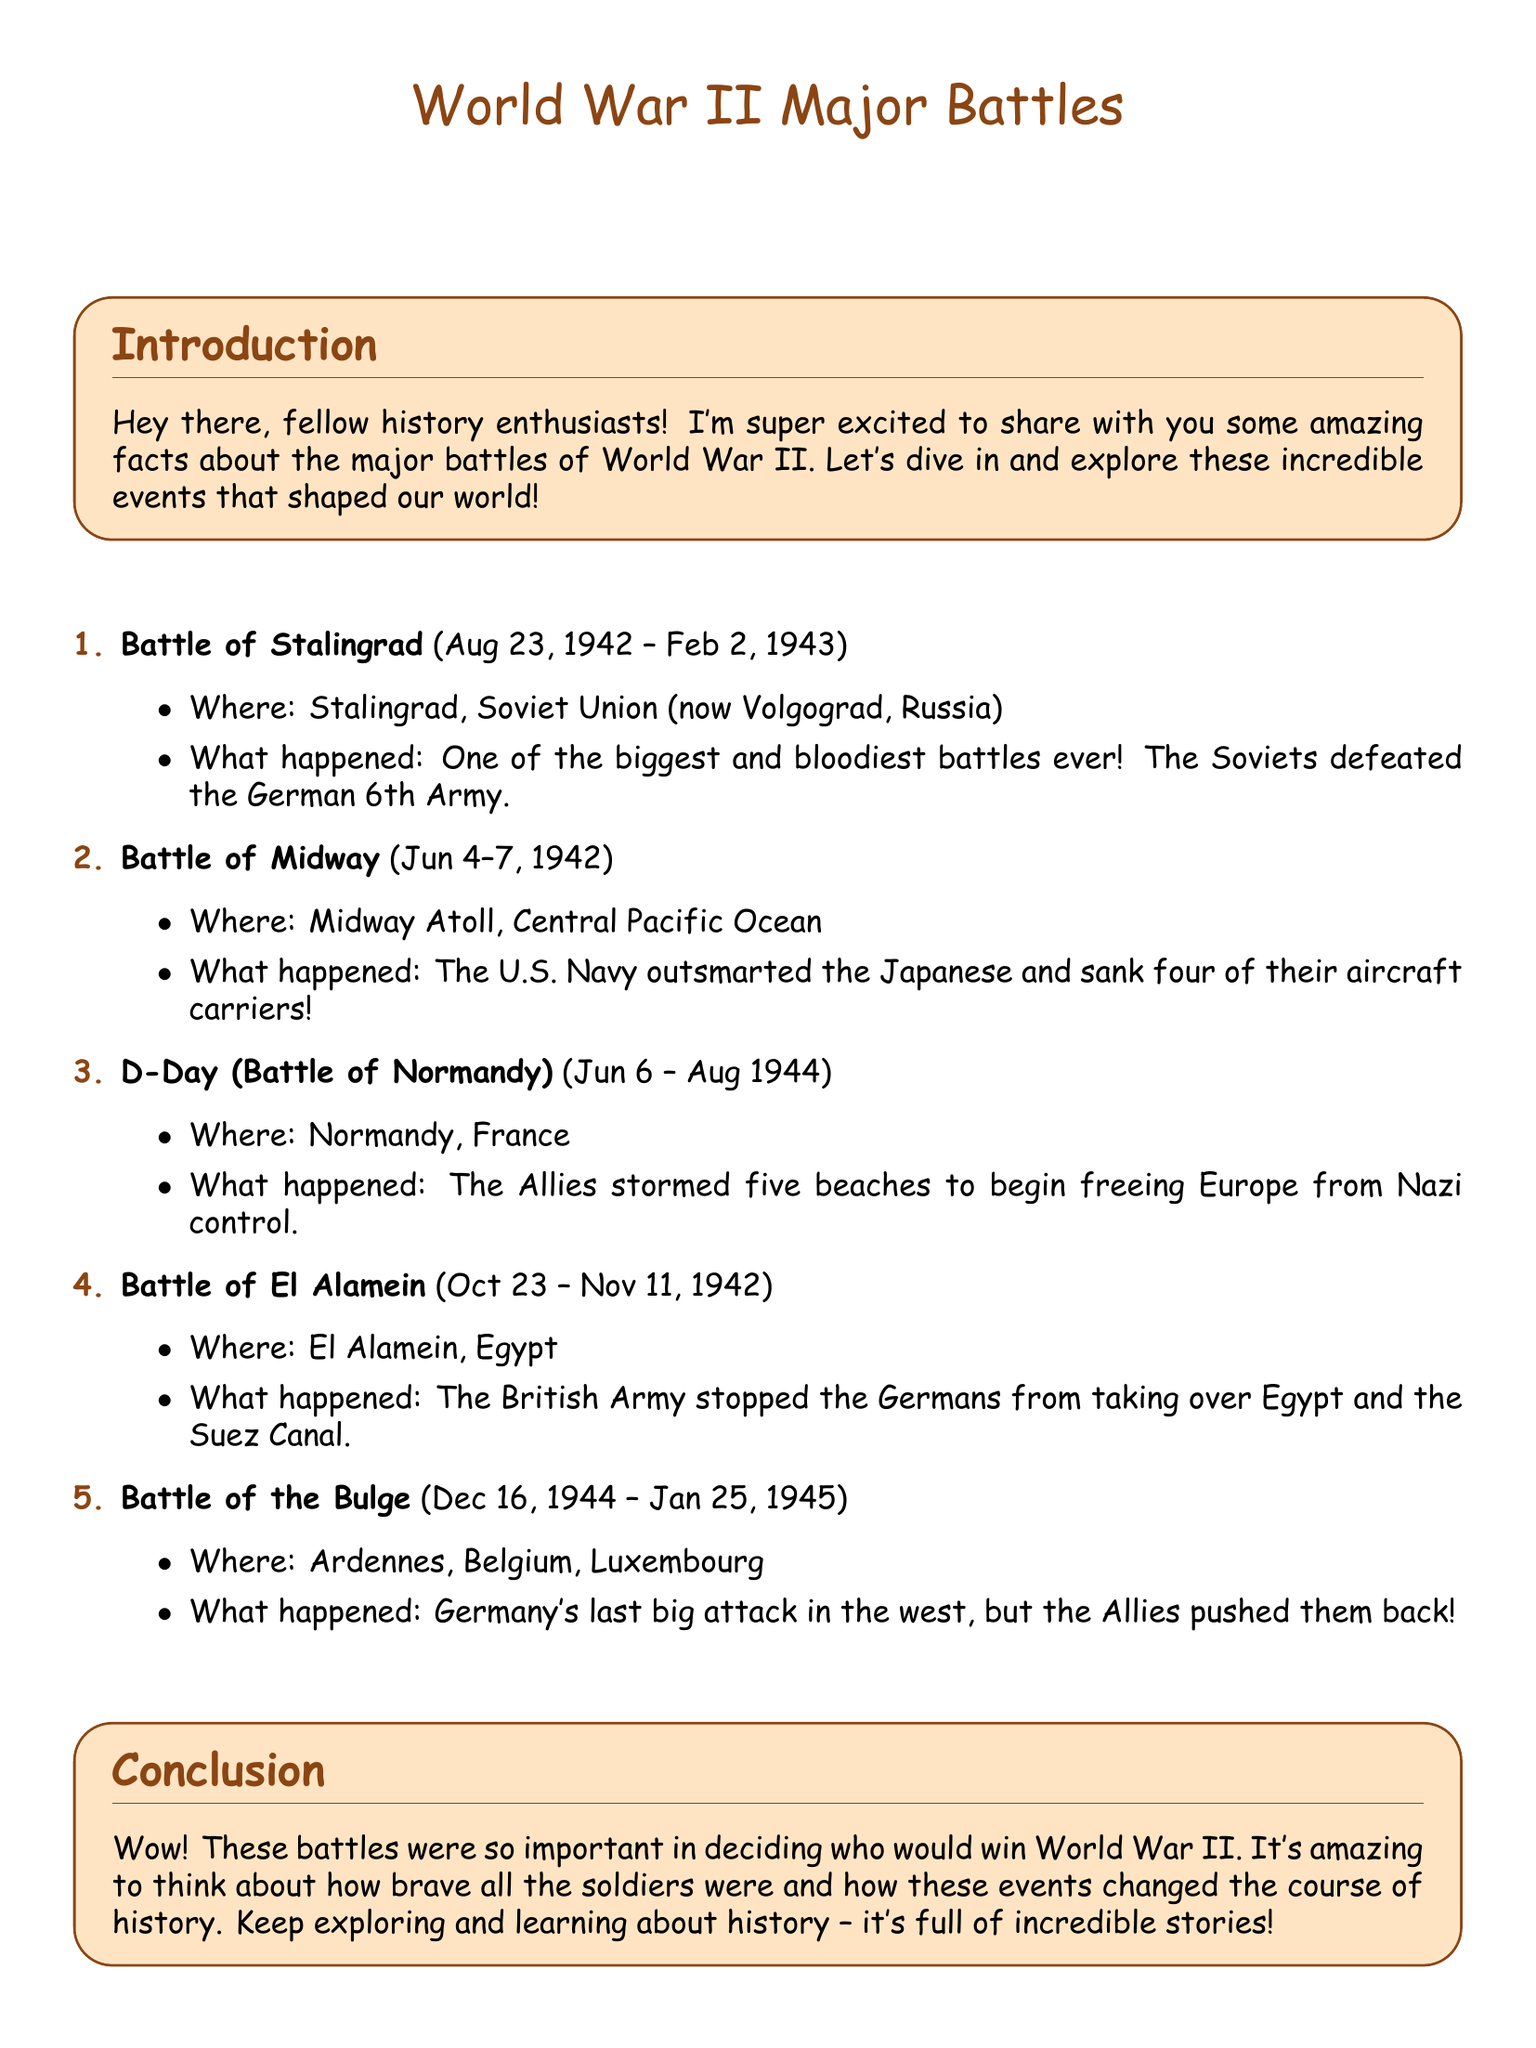What was the date range for the Battle of Stalingrad? The date range for the Battle of Stalingrad is provided in the document as August 23, 1942 to February 2, 1943.
Answer: Aug 23, 1942 – Feb 2, 1943 Where did the Battle of Midway take place? The document specifies that the Battle of Midway occurred at Midway Atoll, Central Pacific Ocean.
Answer: Midway Atoll, Central Pacific Ocean What was a key outcome of D-Day? The document mentions that the Allies stormed five beaches to begin freeing Europe from Nazi control as a key outcome of D-Day.
Answer: Freeing Europe from Nazi control Which battle was the last big attack by Germany in the west? According to the document, the last big attack by Germany in the west was the Battle of the Bulge.
Answer: Battle of the Bulge How long did the Battle of El Alamein last? The document states the Battle of El Alamein lasted from October 23 to November 11, 1942, which is a span of 20 days.
Answer: 20 days What color is the box that contains the introduction? The introduction in the document is contained in a box with a background color described as boxcolor, which is RGB(255,228,196).
Answer: RGB(255,228,196) What is the total number of battles described in the document? The document lists a total of five major battles of World War II.
Answer: 5 Which army stopped the Germans from taking over Egypt? The document specifies that the British Army stopped the Germans from taking over Egypt during the Battle of El Alamein.
Answer: British Army 